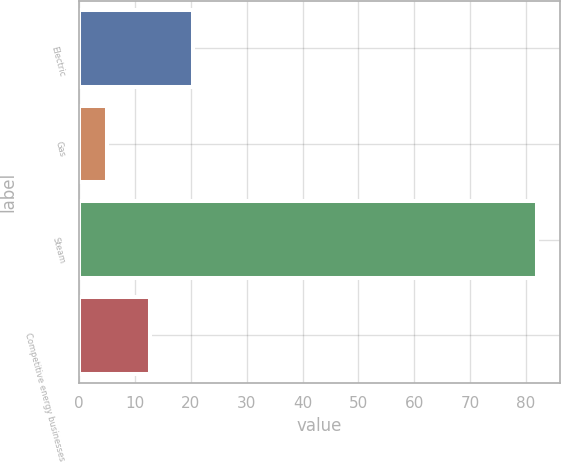Convert chart to OTSL. <chart><loc_0><loc_0><loc_500><loc_500><bar_chart><fcel>Electric<fcel>Gas<fcel>Steam<fcel>Competitive energy businesses<nl><fcel>20.4<fcel>5<fcel>82<fcel>12.7<nl></chart> 